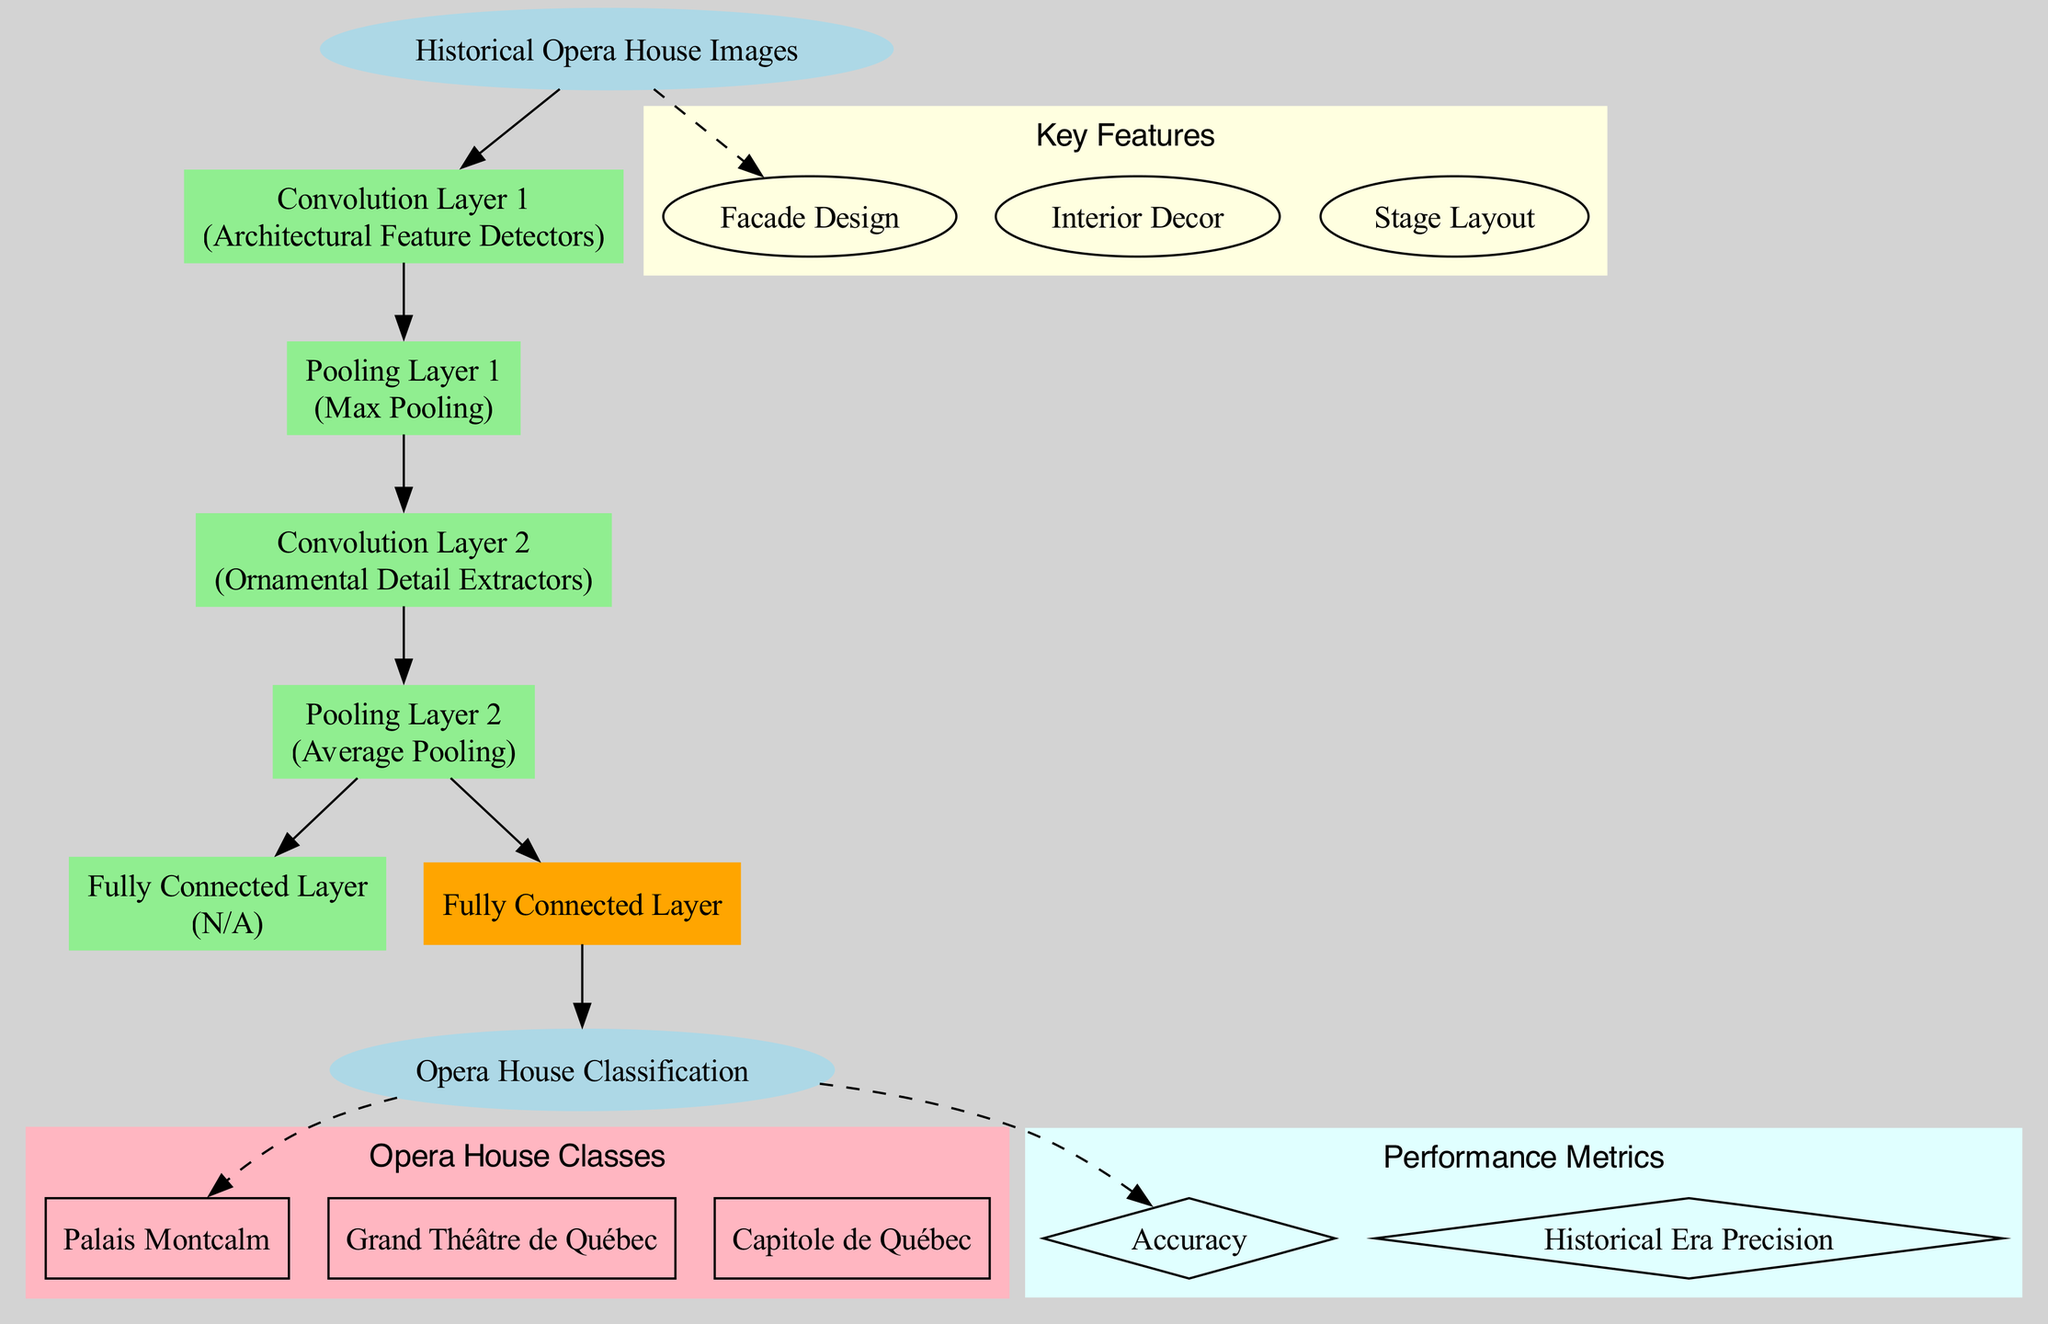What is the input type of the diagram? The diagram identifies the input type at the very beginning, labeled as "Historical Opera House Images." This single node specifies the data type being fed into the convolutional neural network.
Answer: Historical Opera House Images How many convolution layers are present in the diagram? By examining the layers section of the diagram, we find that there are two convolution layers listed: "Convolution Layer 1" and "Convolution Layer 2." Counting these layers gives us the total number, which is 2.
Answer: 2 What type of pooling operation is used in the first pooling layer? The first pooling layer, labeled "Pooling Layer 1," utilizes the "Max Pooling" operation as indicated next to its name in the diagram.
Answer: Max Pooling Which architectural feature is extracted in Convolution Layer 1? The diagram states that "Convolution Layer 1" contains filters designed for "Architectural Feature Detectors." This indicates that this particular layer extracts certain architectural details from the images.
Answer: Architectural Feature Detectors What is the output of the convolutional neural network? The output of the network is stated clearly in the diagram as "Opera House Classification." This is the final node where the results are displayed after processing the input through various layers.
Answer: Opera House Classification In what layer are the opera house styles classified? The "Fully Connected Layer," which comes last before the output, performs the classification of the opera house styles. This can be seen in the connection from the last pooling layer to the output node.
Answer: Fully Connected Layer How many classes are used for opera house classification? The diagram lists three classes associated with the output node: "Palais Montcalm," "Grand Théâtre de Québec," and "Capitole de Québec." By counting these, we find that the total number of classes is three.
Answer: 3 What is the operation performed in Pooling Layer 2? In the diagram, "Pooling Layer 2" is performing "Average Pooling," which is specified next to the layer's name. This operation is responsible for downsampling the feature maps generated from the convolution.
Answer: Average Pooling What are the performance metrics indicated in the diagram? The performance metrics listed in the diagram include "Accuracy" and "Historical Era Precision." These metrics help evaluate the classifier's performance in recognizing different styles of opera houses.
Answer: Accuracy, Historical Era Precision 